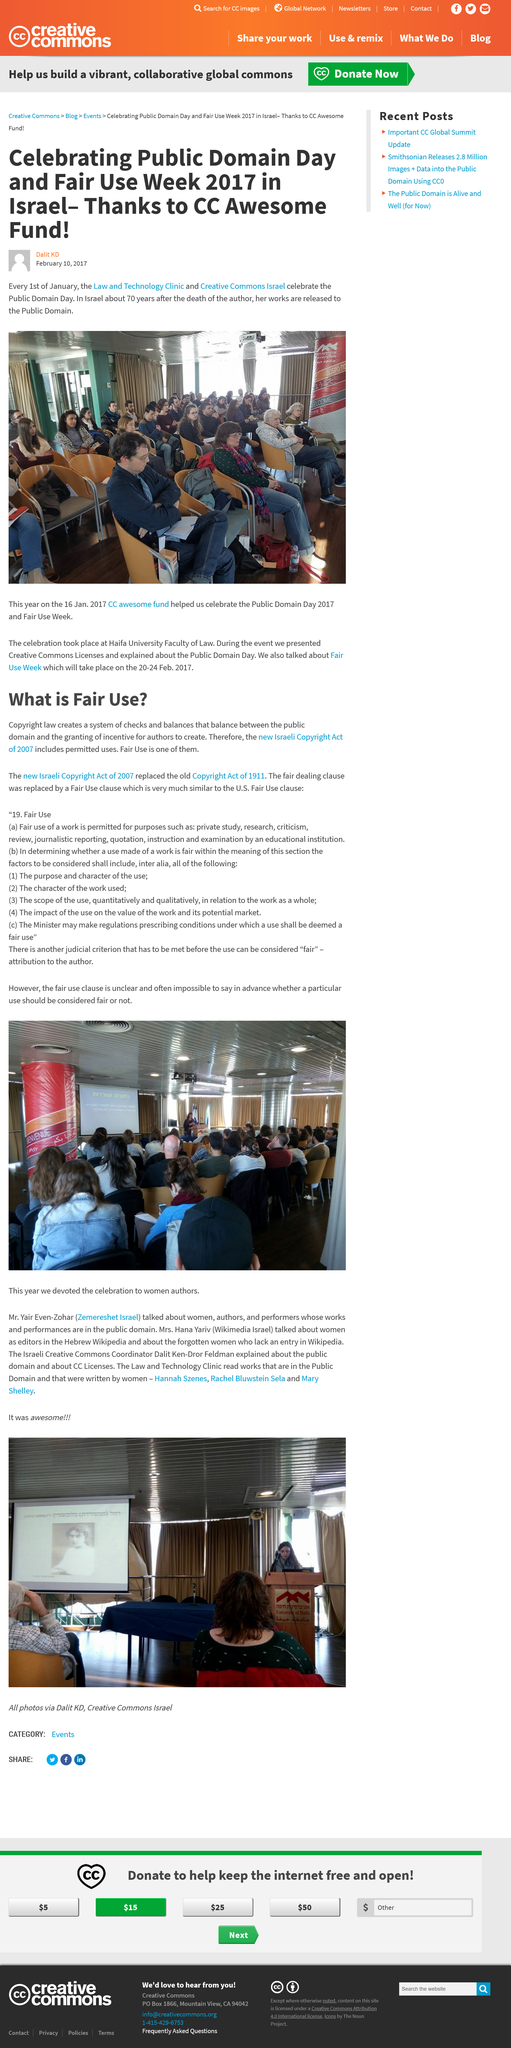Point out several critical features in this image. On January 1st, the Law and Technology Clinic and Creative Commons Israel celebrate Public Domain Day. The article was written by Dalit KD. The title of this text is 'What is the title? What is Fair Use...' and it is asking a question about the title of the text and what Fair Use is. The U.S. Fair Use clause is similar to a Fair Use clause, which allows for limited use of copyrighted material without obtaining permission from the copyright holder. The Israeli Copyright Act of 2007 has replaced the old Copyright Act of 1911. 